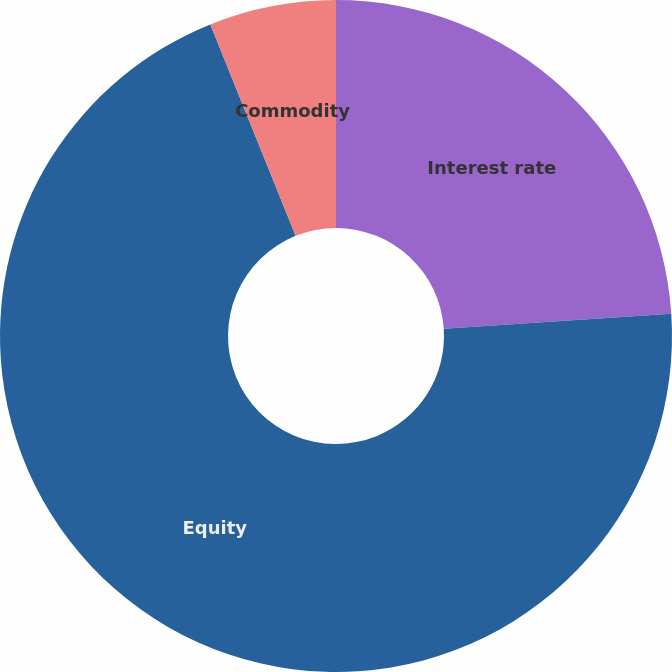<chart> <loc_0><loc_0><loc_500><loc_500><pie_chart><fcel>Interest rate<fcel>Equity<fcel>Commodity<nl><fcel>23.94%<fcel>69.95%<fcel>6.1%<nl></chart> 